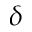Convert formula to latex. <formula><loc_0><loc_0><loc_500><loc_500>\delta</formula> 